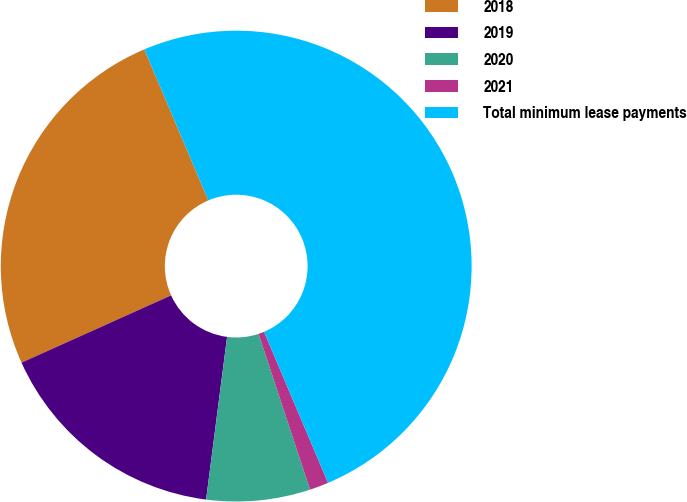<chart> <loc_0><loc_0><loc_500><loc_500><pie_chart><fcel>2018<fcel>2019<fcel>2020<fcel>2021<fcel>Total minimum lease payments<nl><fcel>25.34%<fcel>16.23%<fcel>7.12%<fcel>1.3%<fcel>50.0%<nl></chart> 